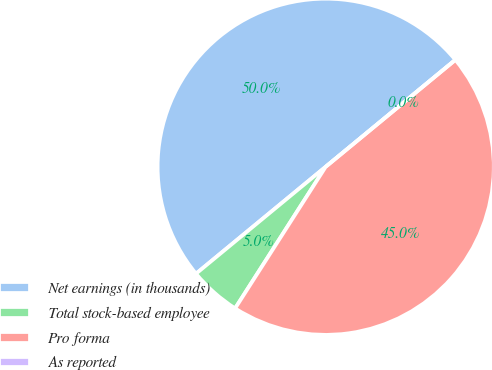Convert chart to OTSL. <chart><loc_0><loc_0><loc_500><loc_500><pie_chart><fcel>Net earnings (in thousands)<fcel>Total stock-based employee<fcel>Pro forma<fcel>As reported<nl><fcel>50.0%<fcel>4.97%<fcel>45.03%<fcel>0.0%<nl></chart> 